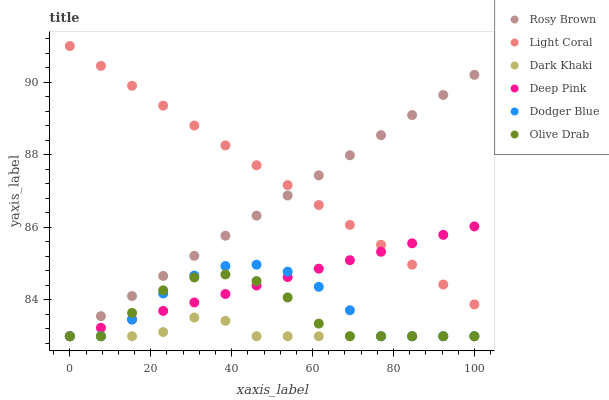Does Dark Khaki have the minimum area under the curve?
Answer yes or no. Yes. Does Light Coral have the maximum area under the curve?
Answer yes or no. Yes. Does Deep Pink have the minimum area under the curve?
Answer yes or no. No. Does Deep Pink have the maximum area under the curve?
Answer yes or no. No. Is Light Coral the smoothest?
Answer yes or no. Yes. Is Dodger Blue the roughest?
Answer yes or no. Yes. Is Deep Pink the smoothest?
Answer yes or no. No. Is Deep Pink the roughest?
Answer yes or no. No. Does Dark Khaki have the lowest value?
Answer yes or no. Yes. Does Light Coral have the lowest value?
Answer yes or no. No. Does Light Coral have the highest value?
Answer yes or no. Yes. Does Deep Pink have the highest value?
Answer yes or no. No. Is Dodger Blue less than Light Coral?
Answer yes or no. Yes. Is Light Coral greater than Dark Khaki?
Answer yes or no. Yes. Does Deep Pink intersect Dodger Blue?
Answer yes or no. Yes. Is Deep Pink less than Dodger Blue?
Answer yes or no. No. Is Deep Pink greater than Dodger Blue?
Answer yes or no. No. Does Dodger Blue intersect Light Coral?
Answer yes or no. No. 